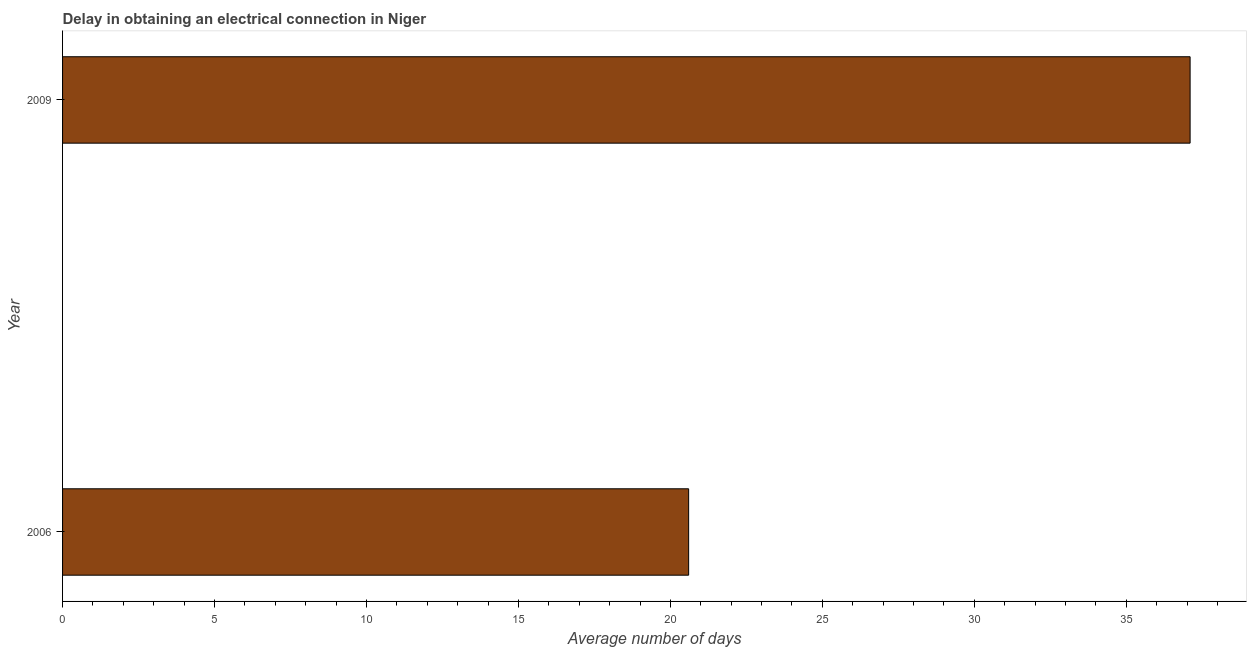Does the graph contain any zero values?
Provide a succinct answer. No. What is the title of the graph?
Provide a short and direct response. Delay in obtaining an electrical connection in Niger. What is the label or title of the X-axis?
Ensure brevity in your answer.  Average number of days. What is the label or title of the Y-axis?
Provide a succinct answer. Year. What is the dalay in electrical connection in 2009?
Make the answer very short. 37.1. Across all years, what is the maximum dalay in electrical connection?
Make the answer very short. 37.1. Across all years, what is the minimum dalay in electrical connection?
Provide a short and direct response. 20.6. In which year was the dalay in electrical connection maximum?
Provide a short and direct response. 2009. In which year was the dalay in electrical connection minimum?
Provide a succinct answer. 2006. What is the sum of the dalay in electrical connection?
Offer a very short reply. 57.7. What is the difference between the dalay in electrical connection in 2006 and 2009?
Make the answer very short. -16.5. What is the average dalay in electrical connection per year?
Give a very brief answer. 28.85. What is the median dalay in electrical connection?
Give a very brief answer. 28.85. In how many years, is the dalay in electrical connection greater than 16 days?
Offer a terse response. 2. What is the ratio of the dalay in electrical connection in 2006 to that in 2009?
Offer a very short reply. 0.56. Is the dalay in electrical connection in 2006 less than that in 2009?
Your response must be concise. Yes. How many years are there in the graph?
Your answer should be very brief. 2. What is the difference between two consecutive major ticks on the X-axis?
Your response must be concise. 5. Are the values on the major ticks of X-axis written in scientific E-notation?
Your response must be concise. No. What is the Average number of days in 2006?
Give a very brief answer. 20.6. What is the Average number of days in 2009?
Make the answer very short. 37.1. What is the difference between the Average number of days in 2006 and 2009?
Offer a very short reply. -16.5. What is the ratio of the Average number of days in 2006 to that in 2009?
Ensure brevity in your answer.  0.56. 